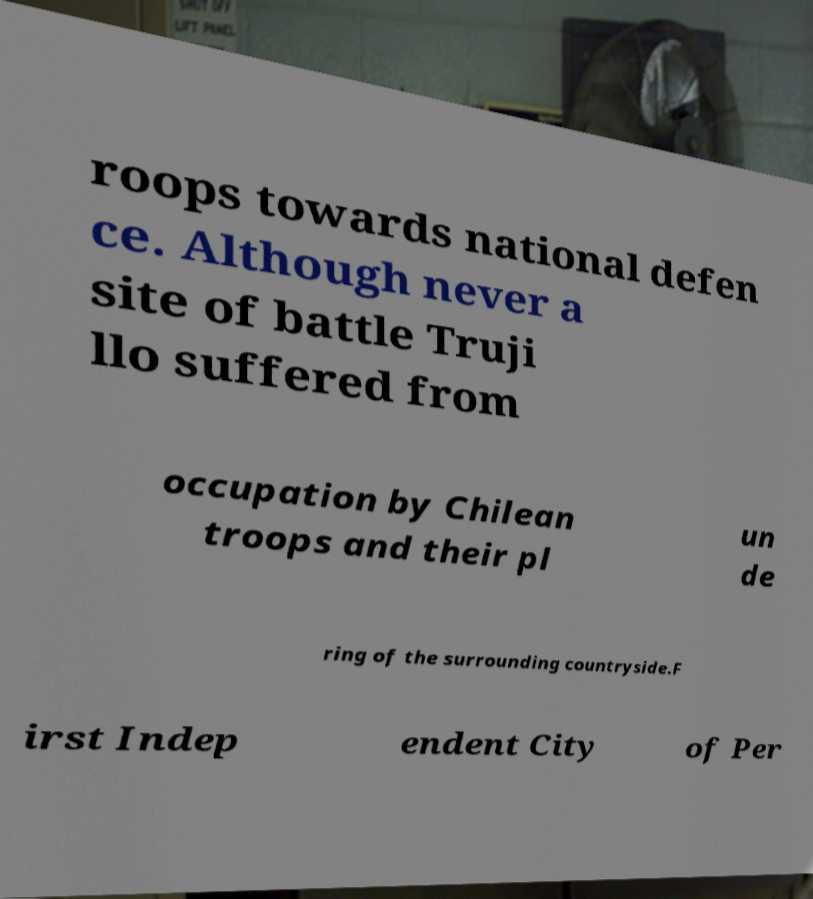I need the written content from this picture converted into text. Can you do that? roops towards national defen ce. Although never a site of battle Truji llo suffered from occupation by Chilean troops and their pl un de ring of the surrounding countryside.F irst Indep endent City of Per 